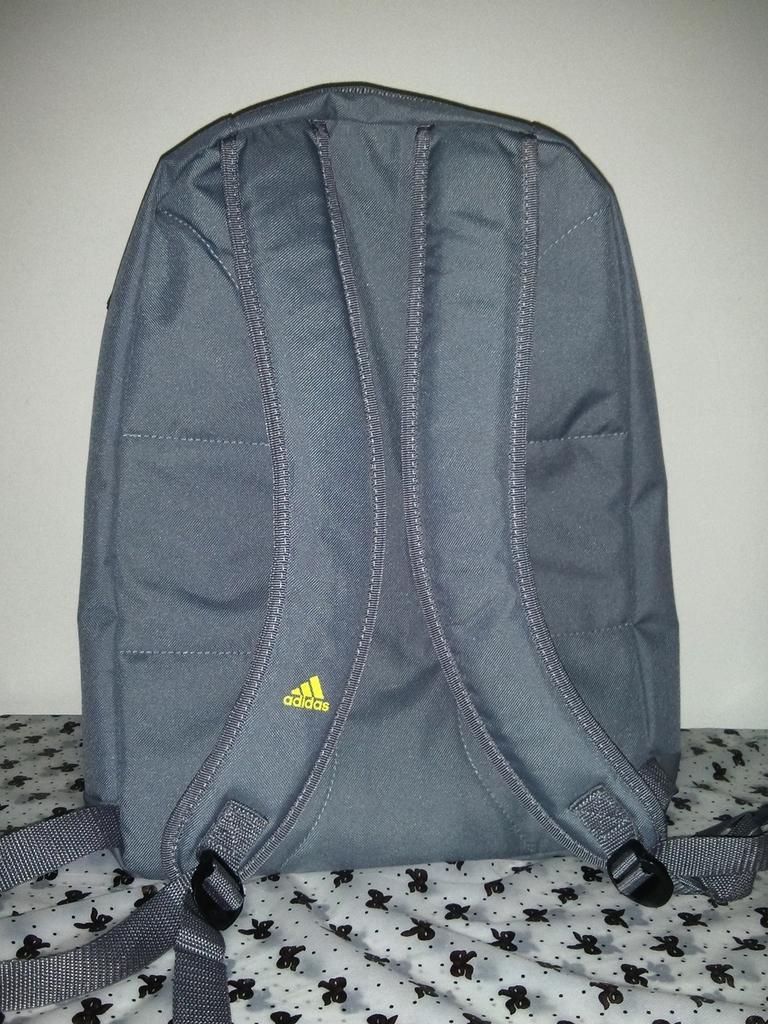What brand of backpack is this?
Your answer should be very brief. Adidas. 